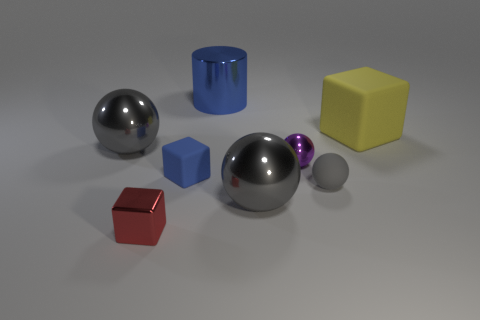What number of large things are both behind the large cube and in front of the yellow rubber object?
Offer a very short reply. 0. There is a blue rubber thing that is the same shape as the tiny red thing; what size is it?
Your answer should be compact. Small. There is a big shiny ball behind the gray metal sphere in front of the purple thing; what number of big gray objects are behind it?
Ensure brevity in your answer.  0. What color is the big metallic object that is behind the sphere that is behind the purple shiny thing?
Make the answer very short. Blue. How many other things are there of the same material as the big cylinder?
Ensure brevity in your answer.  4. There is a large gray metallic object that is behind the tiny purple thing; how many purple metal objects are behind it?
Offer a terse response. 0. Is there any other thing that is the same shape as the big yellow object?
Provide a succinct answer. Yes. There is a small rubber object that is to the left of the small purple metallic ball; is it the same color as the block to the right of the cylinder?
Offer a very short reply. No. Are there fewer tiny gray matte objects than tiny gray rubber cylinders?
Provide a short and direct response. No. There is a yellow object on the right side of the small matte object that is to the left of the cylinder; what is its shape?
Your answer should be very brief. Cube. 